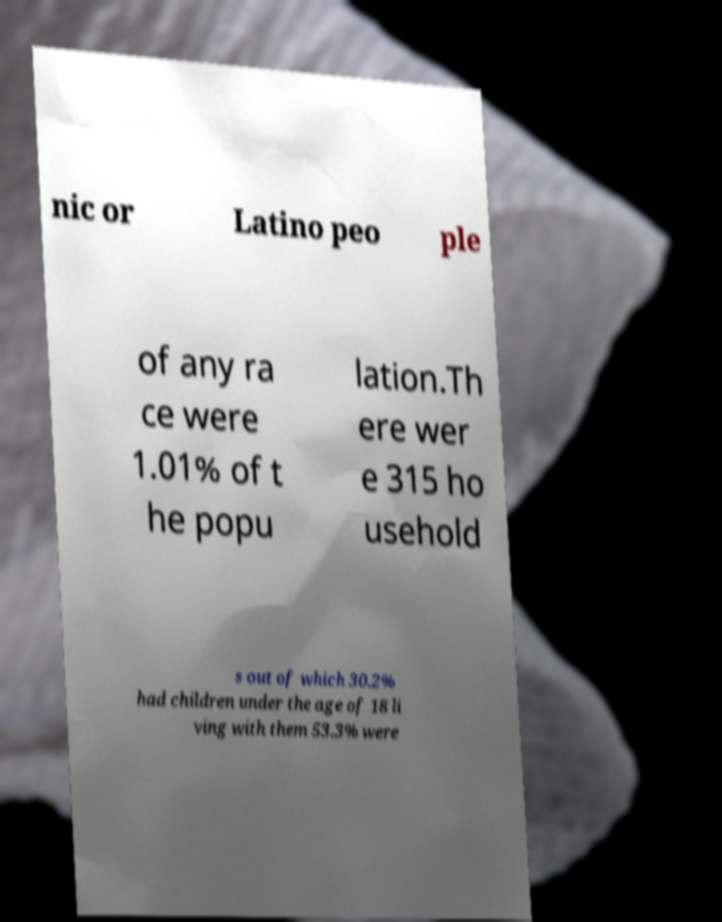Can you read and provide the text displayed in the image?This photo seems to have some interesting text. Can you extract and type it out for me? nic or Latino peo ple of any ra ce were 1.01% of t he popu lation.Th ere wer e 315 ho usehold s out of which 30.2% had children under the age of 18 li ving with them 53.3% were 